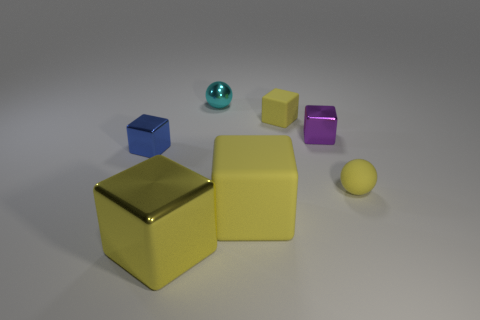What number of tiny cyan objects are there?
Ensure brevity in your answer.  1. What number of cylinders are tiny yellow metallic things or tiny blue shiny objects?
Your response must be concise. 0. What number of cubes are behind the small matte thing in front of the small yellow block?
Offer a terse response. 3. Is the yellow ball made of the same material as the small purple block?
Offer a terse response. No. There is a matte sphere that is the same color as the large shiny cube; what is its size?
Give a very brief answer. Small. Is there a big cyan thing that has the same material as the tiny yellow block?
Make the answer very short. No. What color is the matte block in front of the small yellow matte thing in front of the matte object behind the small blue shiny block?
Give a very brief answer. Yellow. What number of yellow objects are big matte objects or tiny shiny spheres?
Your answer should be very brief. 1. What number of purple things are the same shape as the small blue object?
Offer a terse response. 1. There is a cyan object that is the same size as the yellow sphere; what is its shape?
Your response must be concise. Sphere. 